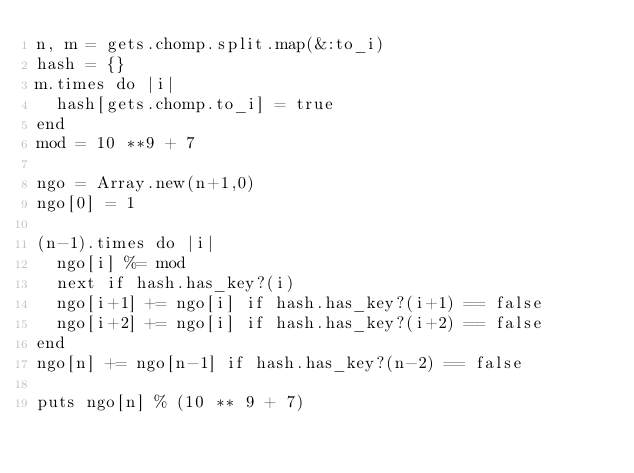<code> <loc_0><loc_0><loc_500><loc_500><_Ruby_>n, m = gets.chomp.split.map(&:to_i)
hash = {}
m.times do |i|
	hash[gets.chomp.to_i] = true 
end
mod = 10 **9 + 7

ngo = Array.new(n+1,0)
ngo[0] = 1

(n-1).times do |i|
	ngo[i] %= mod
	next if hash.has_key?(i)
	ngo[i+1] += ngo[i] if hash.has_key?(i+1) == false 
	ngo[i+2] += ngo[i] if hash.has_key?(i+2) == false 
end
ngo[n] += ngo[n-1] if hash.has_key?(n-2) == false

puts ngo[n] % (10 ** 9 + 7)

</code> 